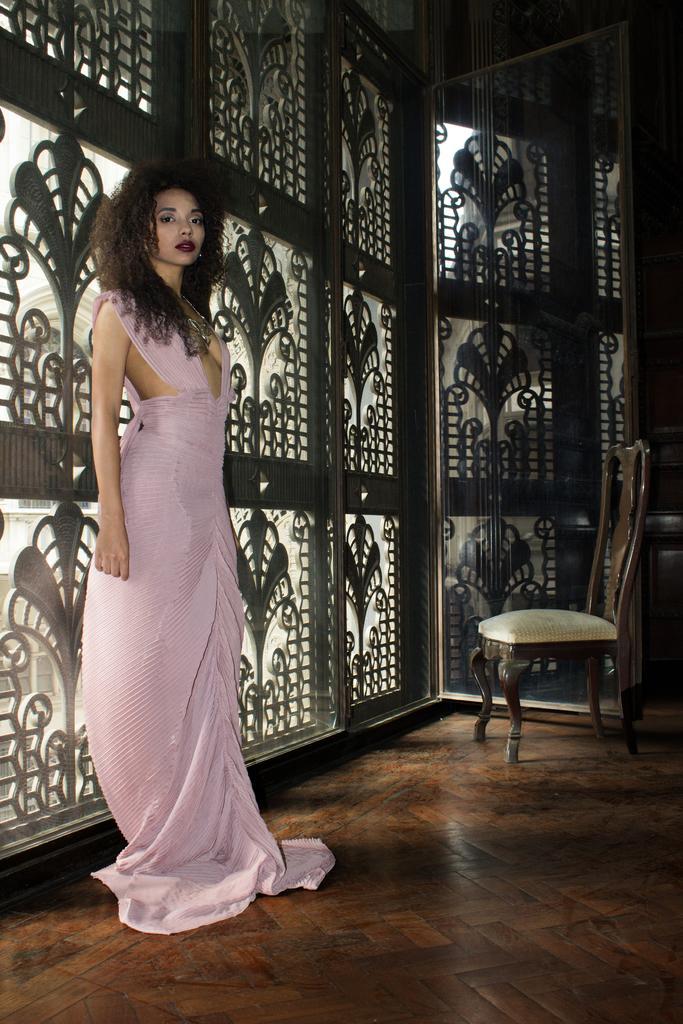How would you summarize this image in a sentence or two? In the image there is a woman stood on the floor and back side of her there is a design wall and in front there is a chair,. 